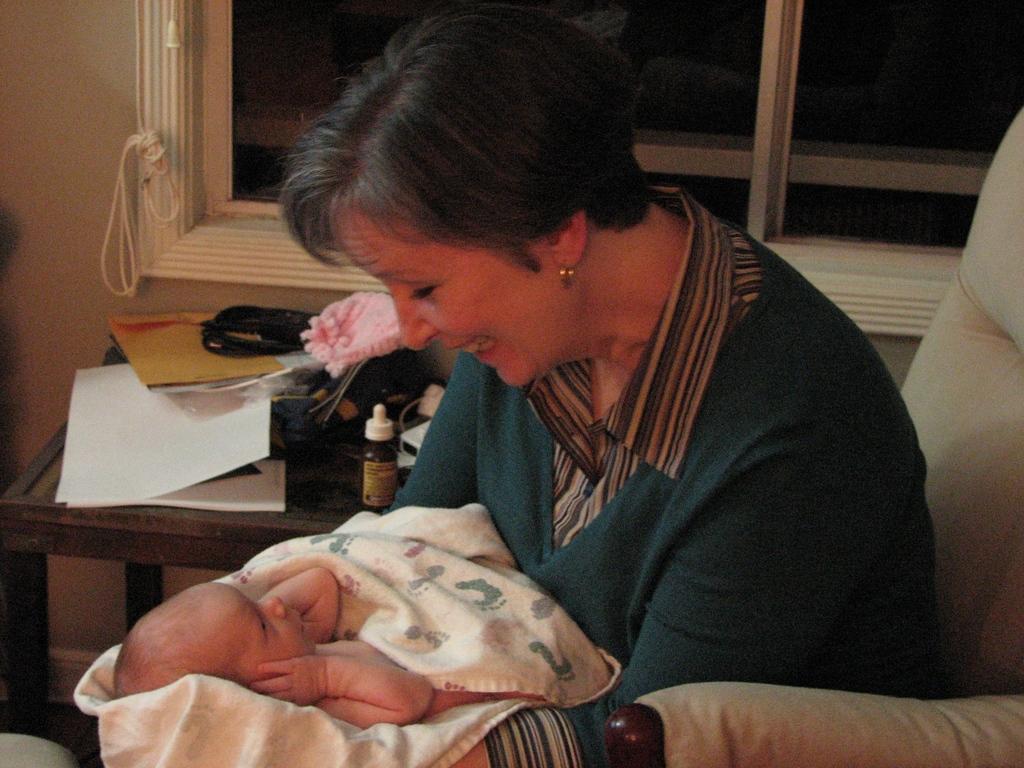In one or two sentences, can you explain what this image depicts? In this image, we can see a person sitting on the couch and holding a baby with her hands. There are things on the table which is on the left side of the image. There is a window at the top of the image. 